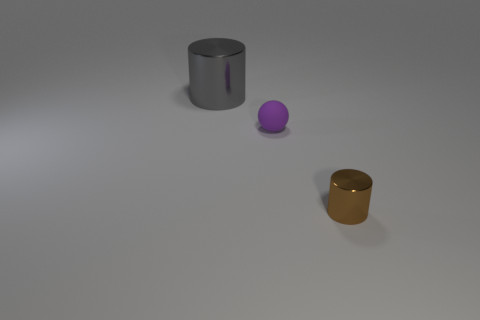What is the color of the thing that is in front of the large object and to the left of the brown object?
Give a very brief answer. Purple. What color is the small object to the left of the metal cylinder on the right side of the metallic object that is behind the tiny brown cylinder?
Your answer should be very brief. Purple. There is another object that is the same size as the purple rubber object; what is its color?
Your answer should be compact. Brown. The tiny object behind the metal object to the right of the metal cylinder behind the small brown object is what shape?
Offer a very short reply. Sphere. What number of objects are either tiny brown shiny cylinders or objects behind the tiny metal object?
Offer a terse response. 3. There is a metal cylinder that is behind the brown cylinder; is its size the same as the tiny brown thing?
Your answer should be compact. No. There is a object behind the ball; what is its material?
Make the answer very short. Metal. Is the number of small things behind the small cylinder the same as the number of small brown shiny cylinders behind the large shiny cylinder?
Your answer should be compact. No. There is a large metallic thing that is the same shape as the small metallic object; what color is it?
Offer a very short reply. Gray. Is there anything else that is the same color as the big shiny cylinder?
Your answer should be very brief. No. 